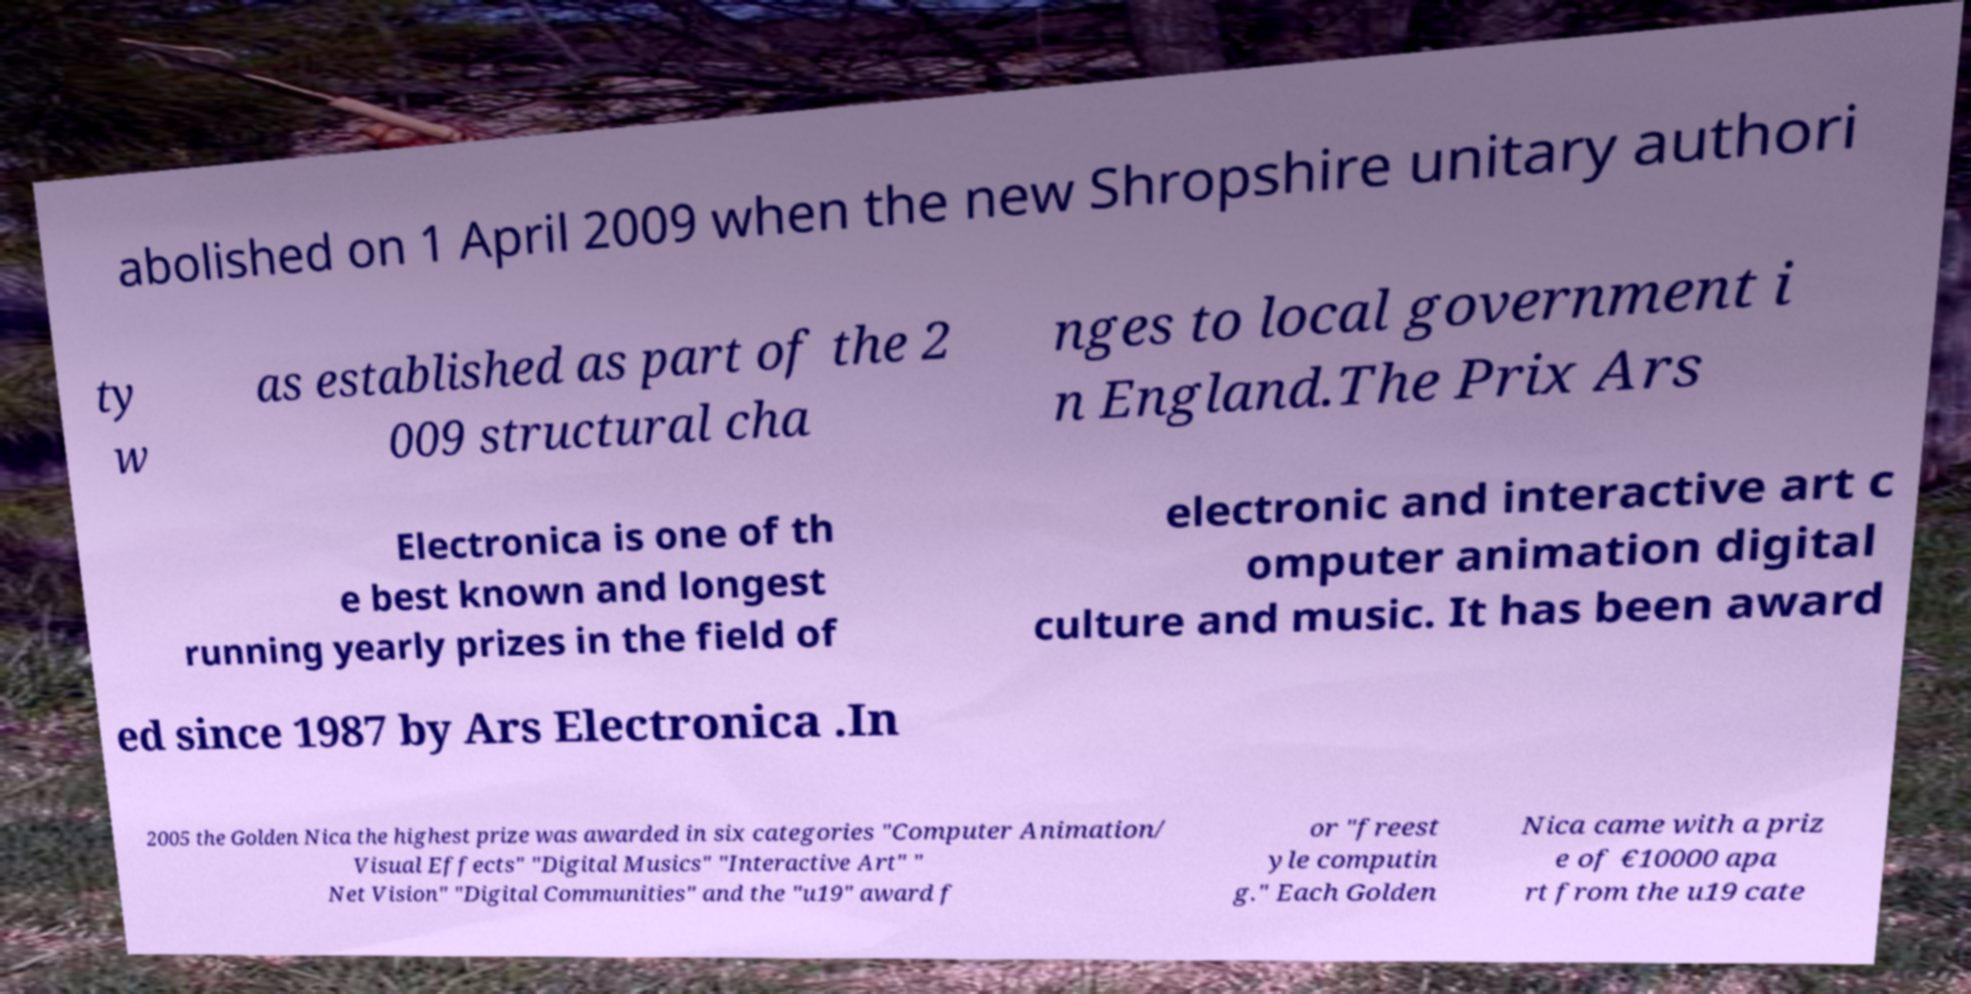There's text embedded in this image that I need extracted. Can you transcribe it verbatim? abolished on 1 April 2009 when the new Shropshire unitary authori ty w as established as part of the 2 009 structural cha nges to local government i n England.The Prix Ars Electronica is one of th e best known and longest running yearly prizes in the field of electronic and interactive art c omputer animation digital culture and music. It has been award ed since 1987 by Ars Electronica .In 2005 the Golden Nica the highest prize was awarded in six categories "Computer Animation/ Visual Effects" "Digital Musics" "Interactive Art" " Net Vision" "Digital Communities" and the "u19" award f or "freest yle computin g." Each Golden Nica came with a priz e of €10000 apa rt from the u19 cate 